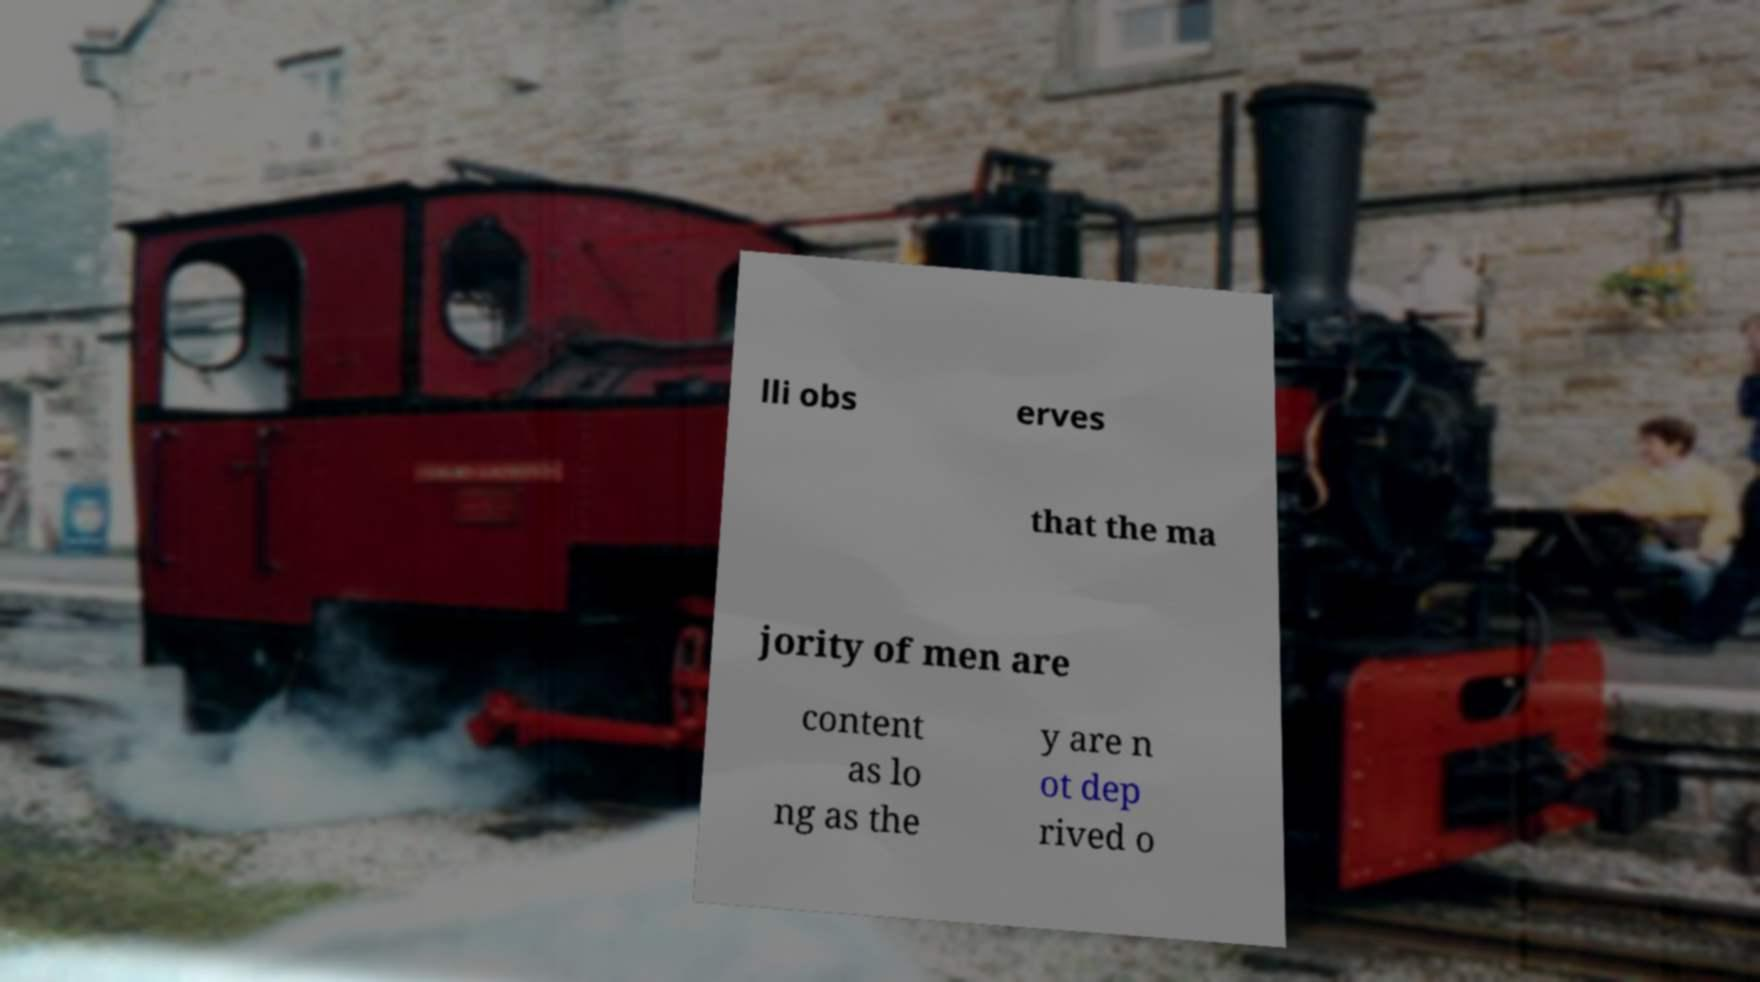There's text embedded in this image that I need extracted. Can you transcribe it verbatim? lli obs erves that the ma jority of men are content as lo ng as the y are n ot dep rived o 